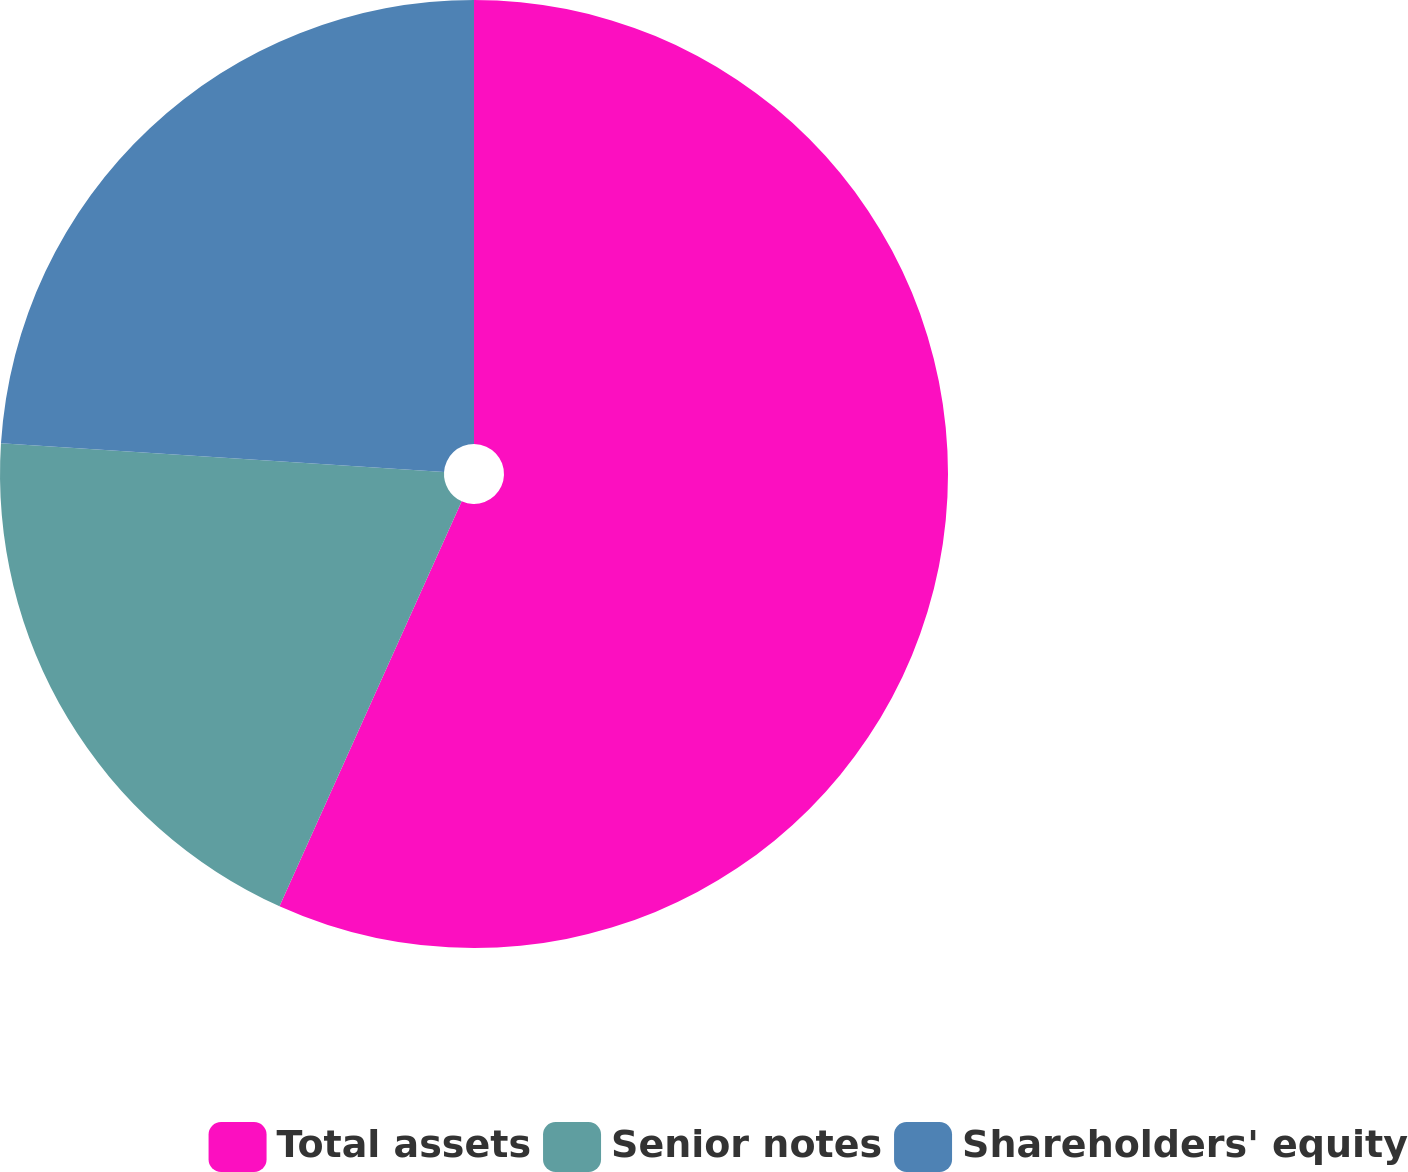<chart> <loc_0><loc_0><loc_500><loc_500><pie_chart><fcel>Total assets<fcel>Senior notes<fcel>Shareholders' equity<nl><fcel>56.73%<fcel>19.3%<fcel>23.97%<nl></chart> 